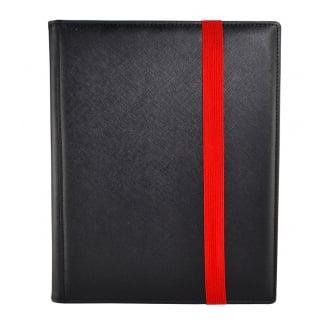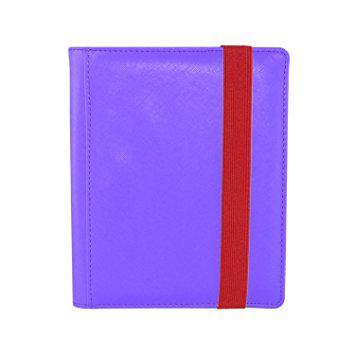The first image is the image on the left, the second image is the image on the right. Analyze the images presented: Is the assertion "An image depicts a purple binder next to an open binder." valid? Answer yes or no. No. 